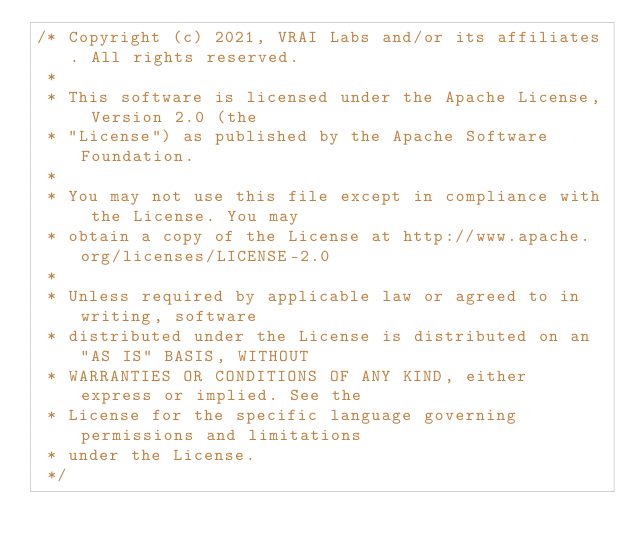<code> <loc_0><loc_0><loc_500><loc_500><_TypeScript_>/* Copyright (c) 2021, VRAI Labs and/or its affiliates. All rights reserved.
 *
 * This software is licensed under the Apache License, Version 2.0 (the
 * "License") as published by the Apache Software Foundation.
 *
 * You may not use this file except in compliance with the License. You may
 * obtain a copy of the License at http://www.apache.org/licenses/LICENSE-2.0
 *
 * Unless required by applicable law or agreed to in writing, software
 * distributed under the License is distributed on an "AS IS" BASIS, WITHOUT
 * WARRANTIES OR CONDITIONS OF ANY KIND, either express or implied. See the
 * License for the specific language governing permissions and limitations
 * under the License.
 */
</code> 